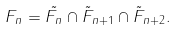Convert formula to latex. <formula><loc_0><loc_0><loc_500><loc_500>F _ { n } = \tilde { F _ { n } } \cap \tilde { F } _ { n + 1 } \cap \tilde { F } _ { n + 2 } .</formula> 